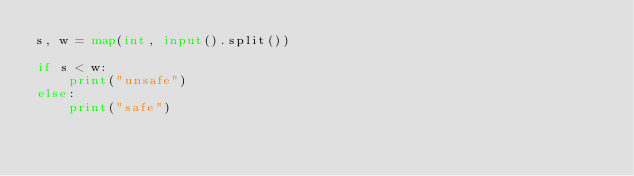Convert code to text. <code><loc_0><loc_0><loc_500><loc_500><_Python_>s, w = map(int, input().split())

if s < w:
    print("unsafe")
else:
    print("safe")</code> 